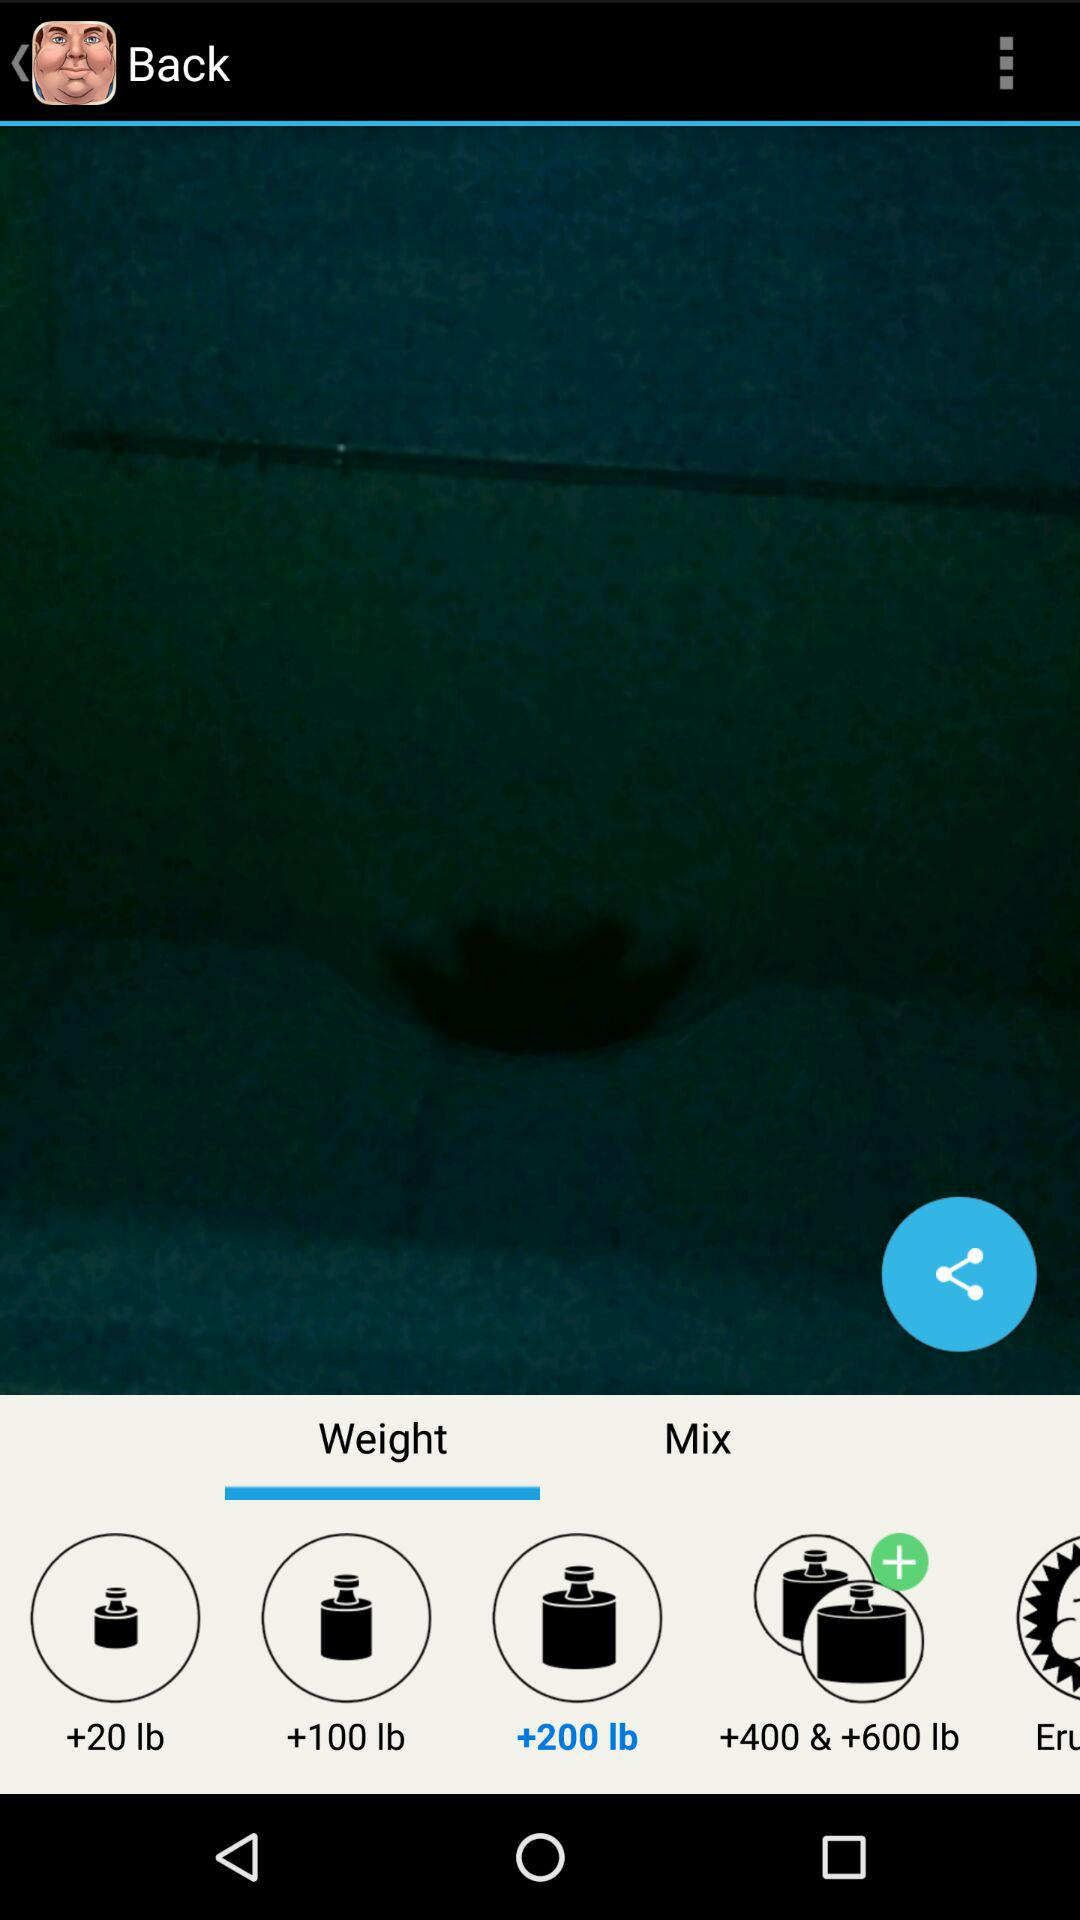What tab am I on? The tab you are on is "Weight". 